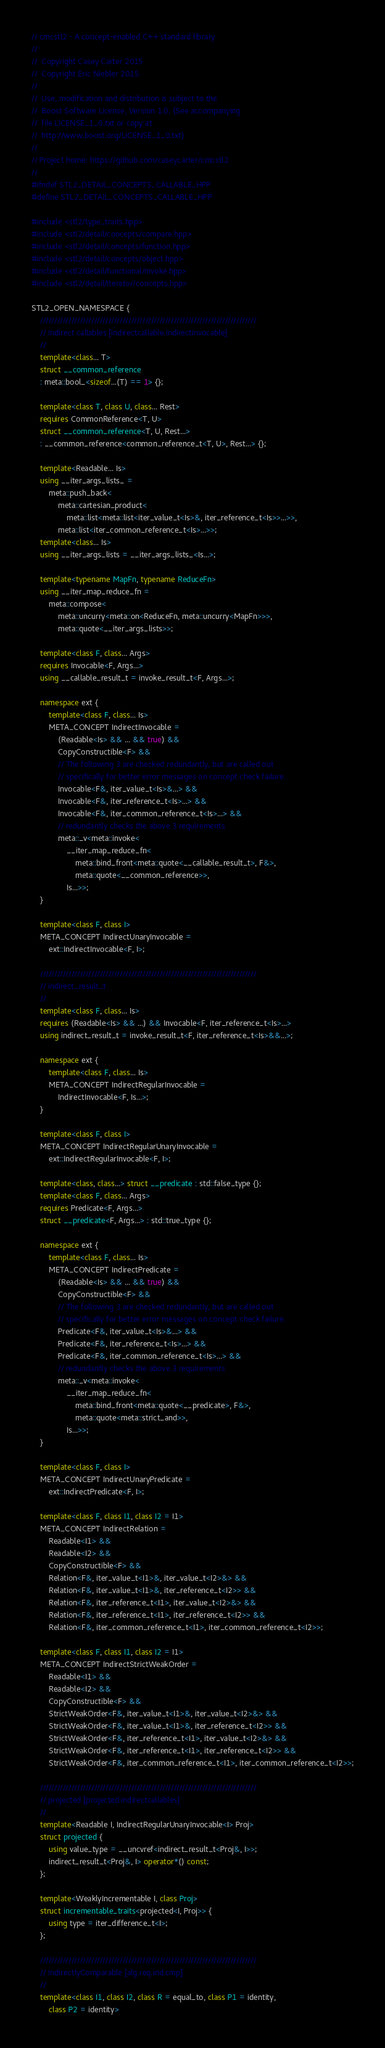<code> <loc_0><loc_0><loc_500><loc_500><_C++_>// cmcstl2 - A concept-enabled C++ standard library
//
//  Copyright Casey Carter 2015
//  Copyright Eric Niebler 2015
//
//  Use, modification and distribution is subject to the
//  Boost Software License, Version 1.0. (See accompanying
//  file LICENSE_1_0.txt or copy at
//  http://www.boost.org/LICENSE_1_0.txt)
//
// Project home: https://github.com/caseycarter/cmcstl2
//
#ifndef STL2_DETAIL_CONCEPTS_CALLABLE_HPP
#define STL2_DETAIL_CONCEPTS_CALLABLE_HPP

#include <stl2/type_traits.hpp>
#include <stl2/detail/concepts/compare.hpp>
#include <stl2/detail/concepts/function.hpp>
#include <stl2/detail/concepts/object.hpp>
#include <stl2/detail/functional/invoke.hpp>
#include <stl2/detail/iterator/concepts.hpp>

STL2_OPEN_NAMESPACE {
	////////////////////////////////////////////////////////////////////////////
	// Indirect callables [indirectcallable.indirectinvocable]
	//
	template<class... T>
	struct __common_reference
	: meta::bool_<sizeof...(T) == 1> {};

	template<class T, class U, class... Rest>
	requires CommonReference<T, U>
	struct __common_reference<T, U, Rest...>
	: __common_reference<common_reference_t<T, U>, Rest...> {};

	template<Readable... Is>
	using __iter_args_lists_ =
		meta::push_back<
			meta::cartesian_product<
				meta::list<meta::list<iter_value_t<Is>&, iter_reference_t<Is>>...>>,
			meta::list<iter_common_reference_t<Is>...>>;
	template<class... Is>
	using __iter_args_lists = __iter_args_lists_<Is...>;

	template<typename MapFn, typename ReduceFn>
	using __iter_map_reduce_fn =
		meta::compose<
			meta::uncurry<meta::on<ReduceFn, meta::uncurry<MapFn>>>,
			meta::quote<__iter_args_lists>>;

	template<class F, class... Args>
	requires Invocable<F, Args...>
	using __callable_result_t = invoke_result_t<F, Args...>;

	namespace ext {
		template<class F, class... Is>
		META_CONCEPT IndirectInvocable =
			(Readable<Is> && ... && true) &&
			CopyConstructible<F> &&
			// The following 3 are checked redundantly, but are called out
			// specifically for better error messages on concept check failure.
			Invocable<F&, iter_value_t<Is>&...> &&
			Invocable<F&, iter_reference_t<Is>...> &&
			Invocable<F&, iter_common_reference_t<Is>...> &&
			// redundantly checks the above 3 requirements
			meta::_v<meta::invoke<
				__iter_map_reduce_fn<
					meta::bind_front<meta::quote<__callable_result_t>, F&>,
					meta::quote<__common_reference>>,
				Is...>>;
	}

	template<class F, class I>
	META_CONCEPT IndirectUnaryInvocable =
		ext::IndirectInvocable<F, I>;

	////////////////////////////////////////////////////////////////////////////
	// indirect_result_t
	//
	template<class F, class... Is>
	requires (Readable<Is> && ...) && Invocable<F, iter_reference_t<Is>...>
	using indirect_result_t = invoke_result_t<F, iter_reference_t<Is>&&...>;

	namespace ext {
		template<class F, class... Is>
		META_CONCEPT IndirectRegularInvocable =
			IndirectInvocable<F, Is...>;
	}

	template<class F, class I>
	META_CONCEPT IndirectRegularUnaryInvocable =
		ext::IndirectRegularInvocable<F, I>;

	template<class, class...> struct __predicate : std::false_type {};
	template<class F, class... Args>
	requires Predicate<F, Args...>
	struct __predicate<F, Args...> : std::true_type {};

	namespace ext {
		template<class F, class... Is>
		META_CONCEPT IndirectPredicate =
			(Readable<Is> && ... && true) &&
			CopyConstructible<F> &&
			// The following 3 are checked redundantly, but are called out
			// specifically for better error messages on concept check failure.
			Predicate<F&, iter_value_t<Is>&...> &&
			Predicate<F&, iter_reference_t<Is>...> &&
			Predicate<F&, iter_common_reference_t<Is>...> &&
			// redundantly checks the above 3 requirements
			meta::_v<meta::invoke<
				__iter_map_reduce_fn<
					meta::bind_front<meta::quote<__predicate>, F&>,
					meta::quote<meta::strict_and>>,
				Is...>>;
	}

	template<class F, class I>
	META_CONCEPT IndirectUnaryPredicate =
		ext::IndirectPredicate<F, I>;

	template<class F, class I1, class I2 = I1>
	META_CONCEPT IndirectRelation =
		Readable<I1> &&
		Readable<I2> &&
		CopyConstructible<F> &&
		Relation<F&, iter_value_t<I1>&, iter_value_t<I2>&> &&
		Relation<F&, iter_value_t<I1>&, iter_reference_t<I2>> &&
		Relation<F&, iter_reference_t<I1>, iter_value_t<I2>&> &&
		Relation<F&, iter_reference_t<I1>, iter_reference_t<I2>> &&
		Relation<F&, iter_common_reference_t<I1>, iter_common_reference_t<I2>>;

	template<class F, class I1, class I2 = I1>
	META_CONCEPT IndirectStrictWeakOrder =
		Readable<I1> &&
		Readable<I2> &&
		CopyConstructible<F> &&
		StrictWeakOrder<F&, iter_value_t<I1>&, iter_value_t<I2>&> &&
		StrictWeakOrder<F&, iter_value_t<I1>&, iter_reference_t<I2>> &&
		StrictWeakOrder<F&, iter_reference_t<I1>, iter_value_t<I2>&> &&
		StrictWeakOrder<F&, iter_reference_t<I1>, iter_reference_t<I2>> &&
		StrictWeakOrder<F&, iter_common_reference_t<I1>, iter_common_reference_t<I2>>;

	////////////////////////////////////////////////////////////////////////////
	// projected [projected.indirectcallables]
	//
	template<Readable I, IndirectRegularUnaryInvocable<I> Proj>
	struct projected {
		using value_type = __uncvref<indirect_result_t<Proj&, I>>;
		indirect_result_t<Proj&, I> operator*() const;
	};

	template<WeaklyIncrementable I, class Proj>
	struct incrementable_traits<projected<I, Proj>> {
		using type = iter_difference_t<I>;
	};

	////////////////////////////////////////////////////////////////////////////
	// IndirectlyComparable [alg.req.ind.cmp]
	//
	template<class I1, class I2, class R = equal_to, class P1 = identity,
		class P2 = identity></code> 